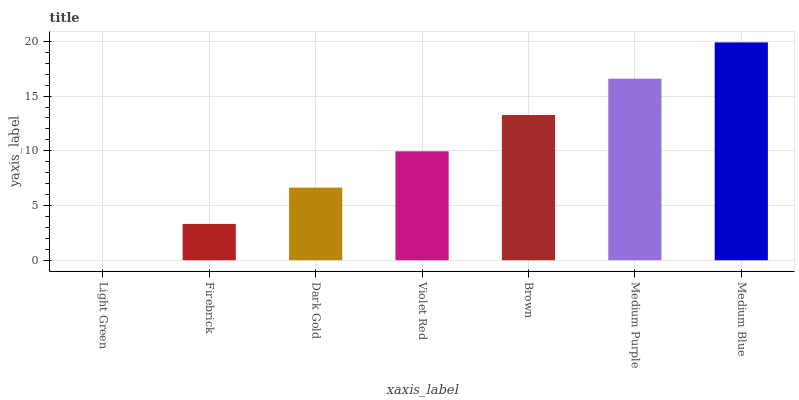Is Light Green the minimum?
Answer yes or no. Yes. Is Medium Blue the maximum?
Answer yes or no. Yes. Is Firebrick the minimum?
Answer yes or no. No. Is Firebrick the maximum?
Answer yes or no. No. Is Firebrick greater than Light Green?
Answer yes or no. Yes. Is Light Green less than Firebrick?
Answer yes or no. Yes. Is Light Green greater than Firebrick?
Answer yes or no. No. Is Firebrick less than Light Green?
Answer yes or no. No. Is Violet Red the high median?
Answer yes or no. Yes. Is Violet Red the low median?
Answer yes or no. Yes. Is Dark Gold the high median?
Answer yes or no. No. Is Firebrick the low median?
Answer yes or no. No. 